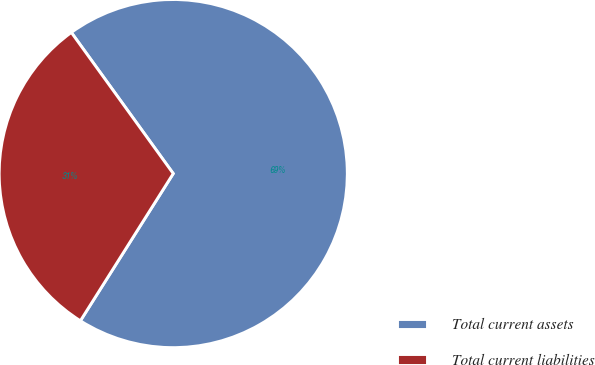Convert chart to OTSL. <chart><loc_0><loc_0><loc_500><loc_500><pie_chart><fcel>Total current assets<fcel>Total current liabilities<nl><fcel>68.91%<fcel>31.09%<nl></chart> 